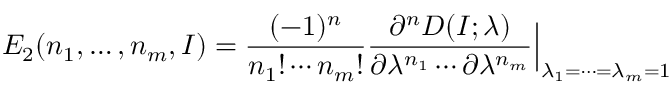Convert formula to latex. <formula><loc_0><loc_0><loc_500><loc_500>E _ { 2 } ( n _ { 1 } , \dots , n _ { m } , I ) = { \frac { ( - 1 ) ^ { n } } { n _ { 1 } ! \cdots n _ { m } ! } } { \frac { \partial ^ { n } D ( I ; \lambda ) } { \partial \lambda ^ { n _ { 1 } } \cdots \partial \lambda ^ { n _ { m } } } } \Big | _ { \lambda _ { 1 } = \cdots = \lambda _ { m } = 1 }</formula> 